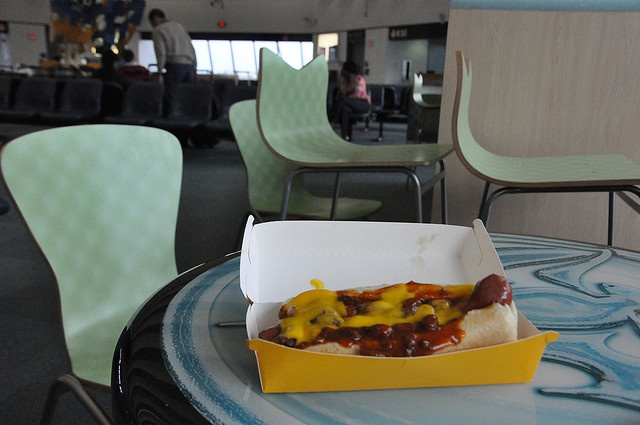Describe the objects in this image and their specific colors. I can see dining table in gray, darkgray, black, and olive tones, chair in gray, darkgray, and black tones, hot dog in gray, maroon, olive, black, and tan tones, chair in gray, black, and darkgray tones, and chair in gray, darkgray, and black tones in this image. 